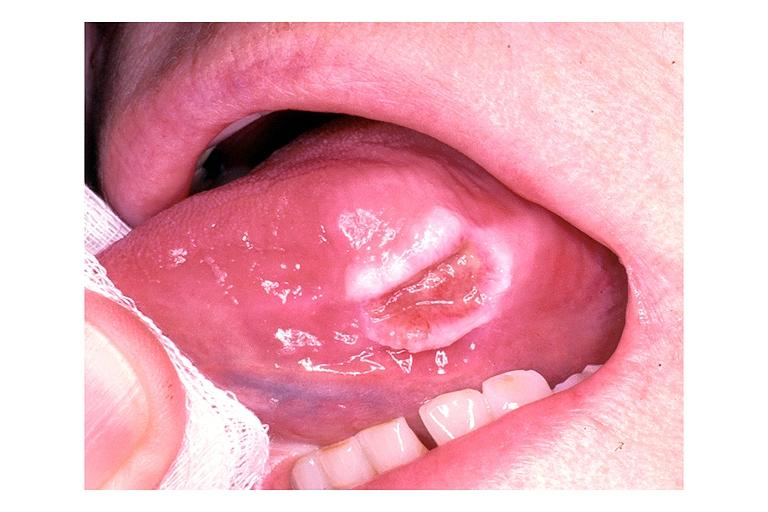where is this?
Answer the question using a single word or phrase. Oral 